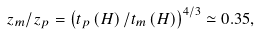Convert formula to latex. <formula><loc_0><loc_0><loc_500><loc_500>z _ { m } / z _ { p } = \left ( t _ { p } \left ( H \right ) / t _ { m } \left ( H \right ) \right ) ^ { 4 / 3 } \simeq 0 . 3 5 ,</formula> 